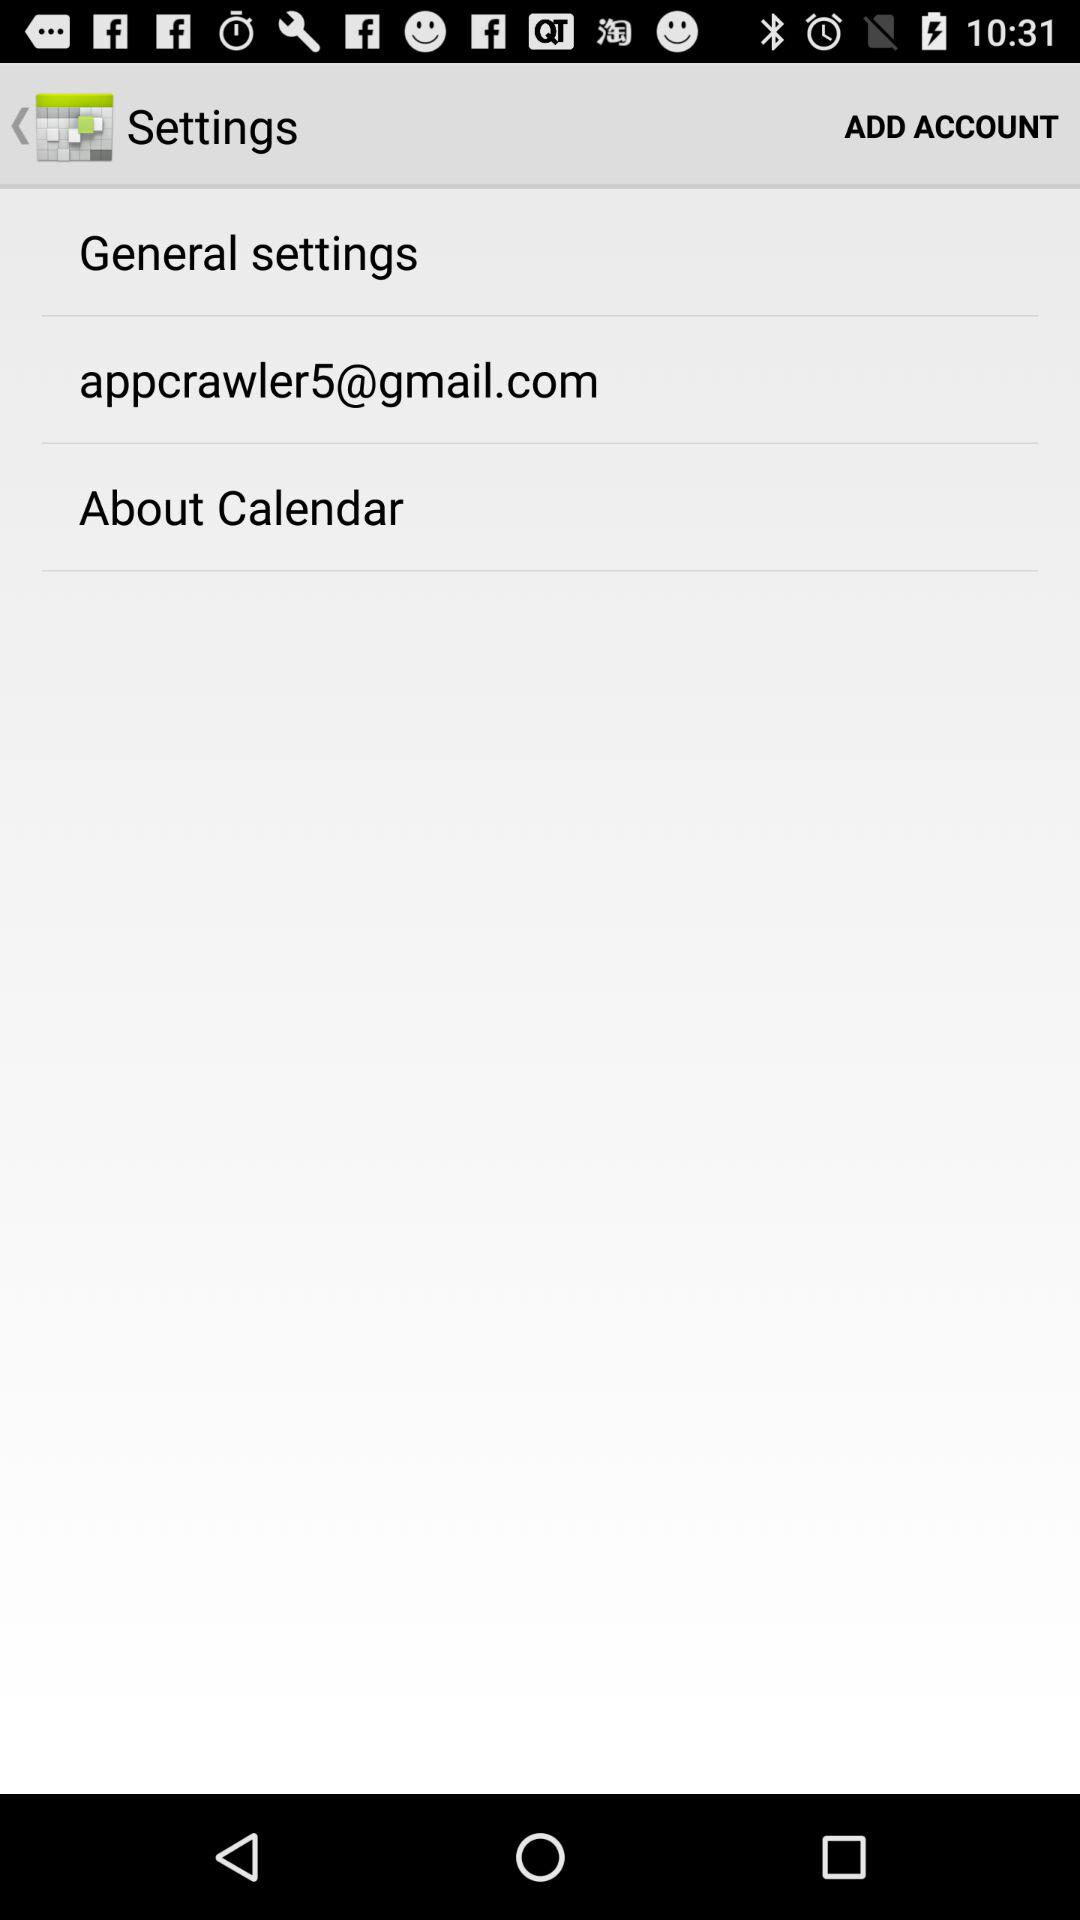What is the email address? The email address is appcrawler5@gmail.com. 